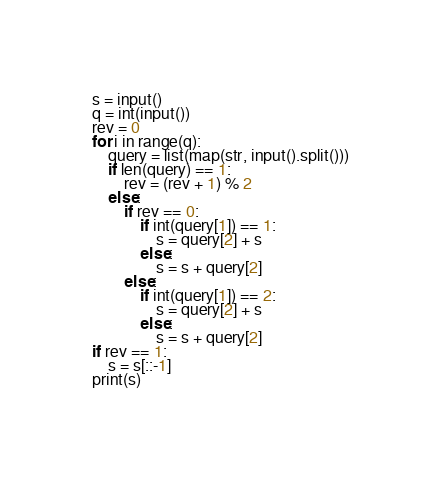Convert code to text. <code><loc_0><loc_0><loc_500><loc_500><_Python_>s = input()
q = int(input())
rev = 0
for i in range(q):
    query = list(map(str, input().split()))
    if len(query) == 1:
        rev = (rev + 1) % 2
    else:
        if rev == 0:
            if int(query[1]) == 1:
                s = query[2] + s
            else:
                s = s + query[2]
        else:
            if int(query[1]) == 2:
                s = query[2] + s
            else:
                s = s + query[2]
if rev == 1:
    s = s[::-1]
print(s)</code> 